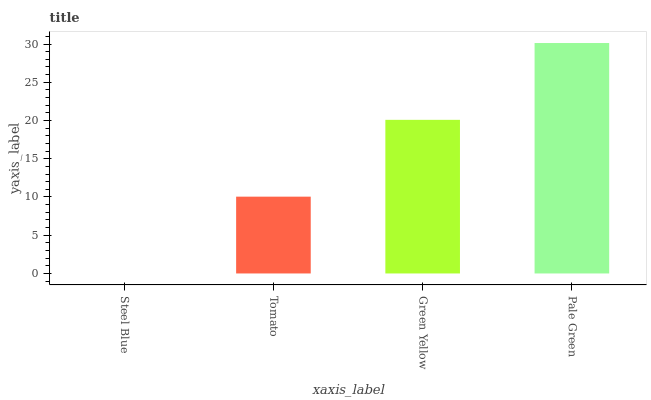Is Steel Blue the minimum?
Answer yes or no. Yes. Is Pale Green the maximum?
Answer yes or no. Yes. Is Tomato the minimum?
Answer yes or no. No. Is Tomato the maximum?
Answer yes or no. No. Is Tomato greater than Steel Blue?
Answer yes or no. Yes. Is Steel Blue less than Tomato?
Answer yes or no. Yes. Is Steel Blue greater than Tomato?
Answer yes or no. No. Is Tomato less than Steel Blue?
Answer yes or no. No. Is Green Yellow the high median?
Answer yes or no. Yes. Is Tomato the low median?
Answer yes or no. Yes. Is Steel Blue the high median?
Answer yes or no. No. Is Steel Blue the low median?
Answer yes or no. No. 